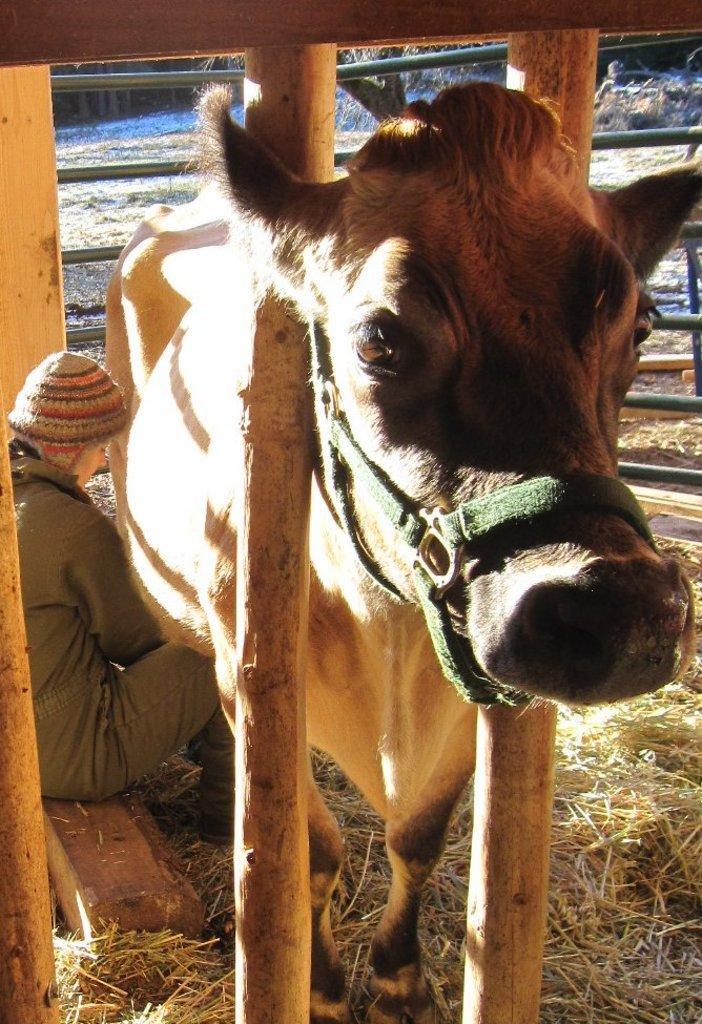Describe this image in one or two sentences. In this image there is a woman sitting, there is a cow, there is a wooden fence, there is dried grass on the ground, there is a tree trunk, there are objects towards the right of the image. 